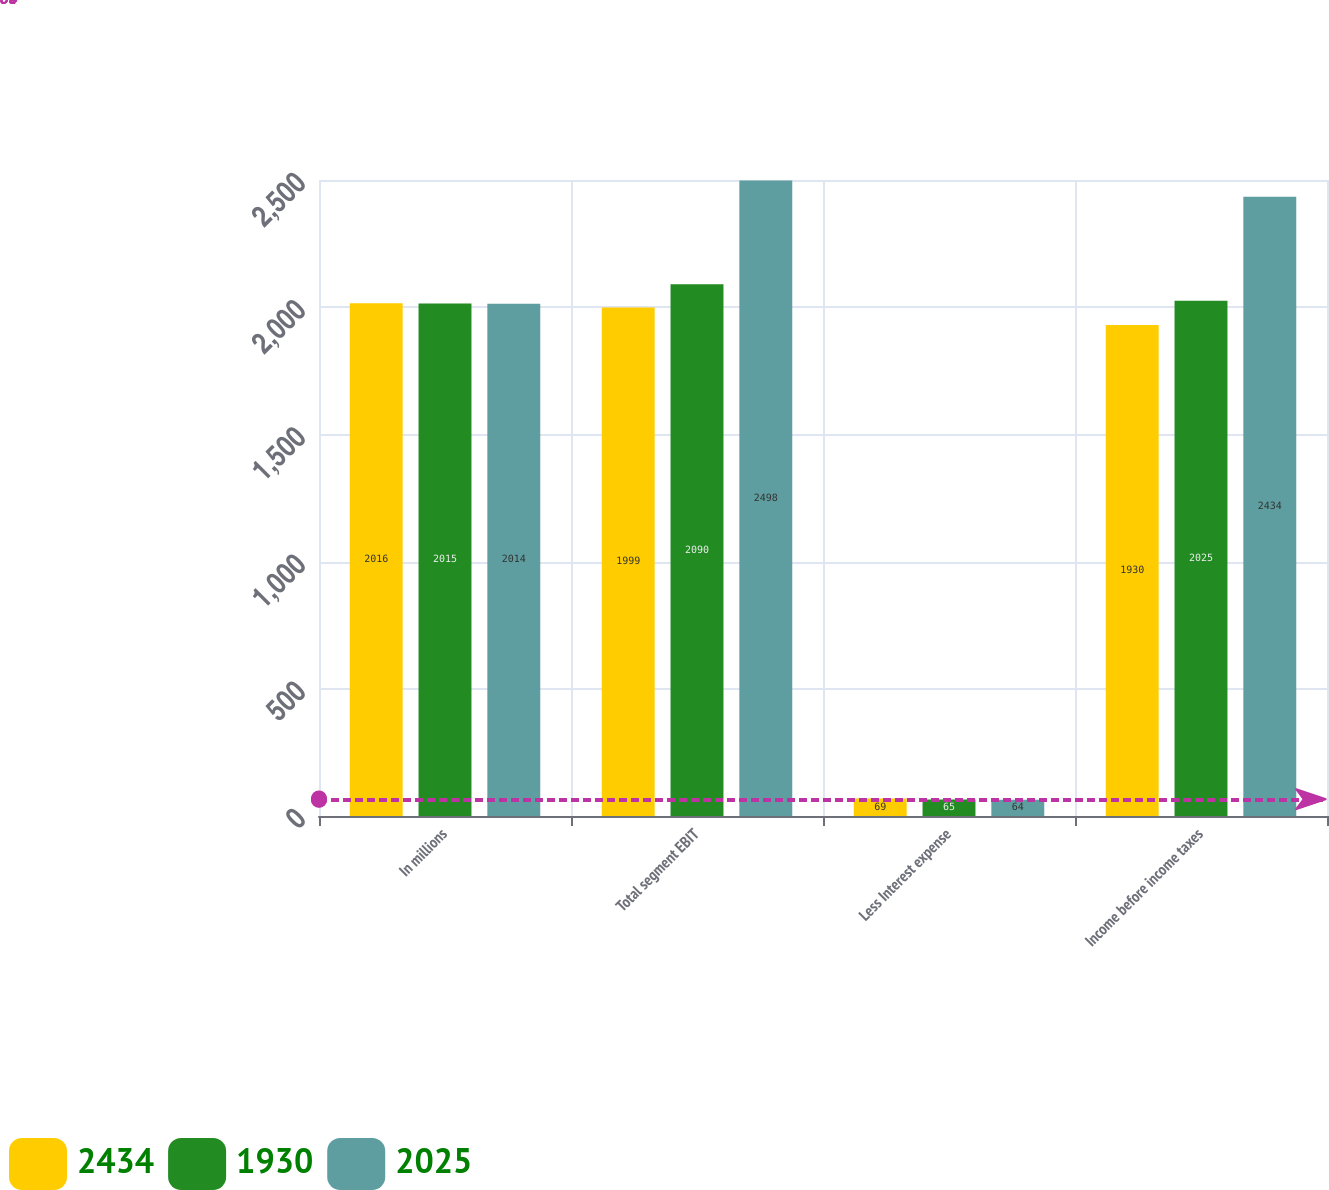<chart> <loc_0><loc_0><loc_500><loc_500><stacked_bar_chart><ecel><fcel>In millions<fcel>Total segment EBIT<fcel>Less Interest expense<fcel>Income before income taxes<nl><fcel>2434<fcel>2016<fcel>1999<fcel>69<fcel>1930<nl><fcel>1930<fcel>2015<fcel>2090<fcel>65<fcel>2025<nl><fcel>2025<fcel>2014<fcel>2498<fcel>64<fcel>2434<nl></chart> 